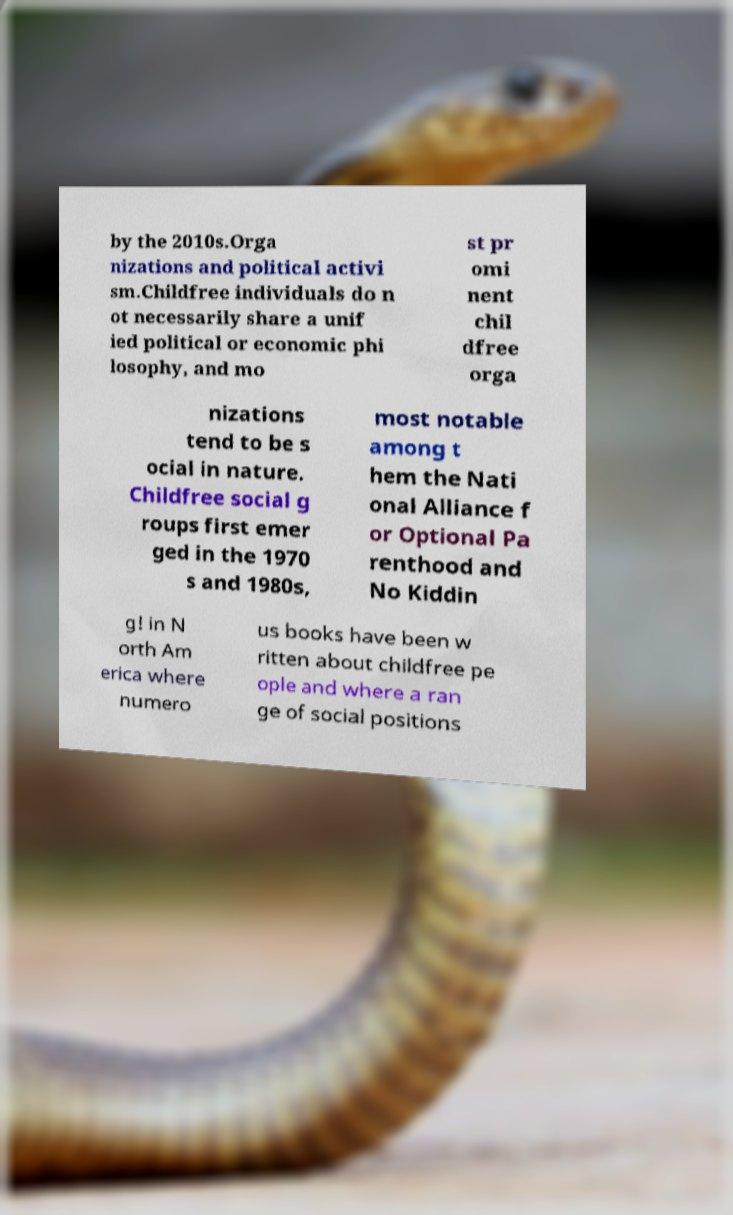What messages or text are displayed in this image? I need them in a readable, typed format. by the 2010s.Orga nizations and political activi sm.Childfree individuals do n ot necessarily share a unif ied political or economic phi losophy, and mo st pr omi nent chil dfree orga nizations tend to be s ocial in nature. Childfree social g roups first emer ged in the 1970 s and 1980s, most notable among t hem the Nati onal Alliance f or Optional Pa renthood and No Kiddin g! in N orth Am erica where numero us books have been w ritten about childfree pe ople and where a ran ge of social positions 